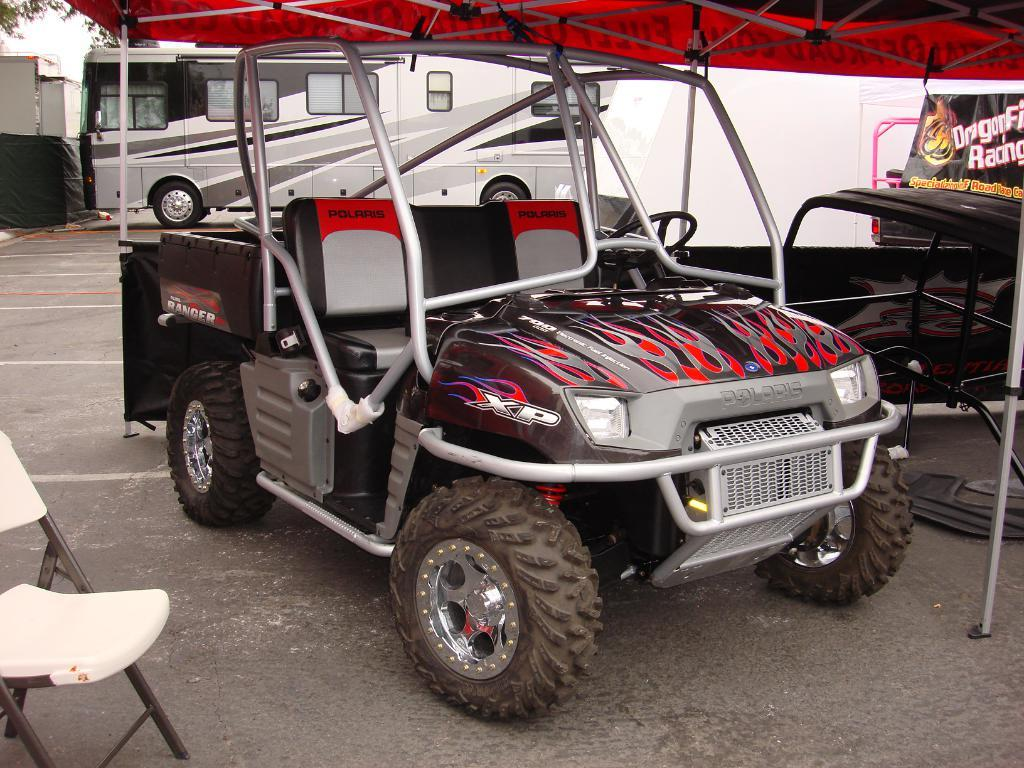What is the main subject in the foreground of the image? There is a vehicle in the foreground of the image. What can be seen in the background of the image? There is a bus in the background of the image. Where is the chair located in the image? The chair is on the left side of the image. What is on the right side of the image? There is a banner on the right side of the image. What type of button can be seen on the vehicle in the image? There is no button visible on the vehicle in the image. What is the desire of the person holding the banner in the image? There is no person holding the banner in the image, so it is not possible to determine their desire. 